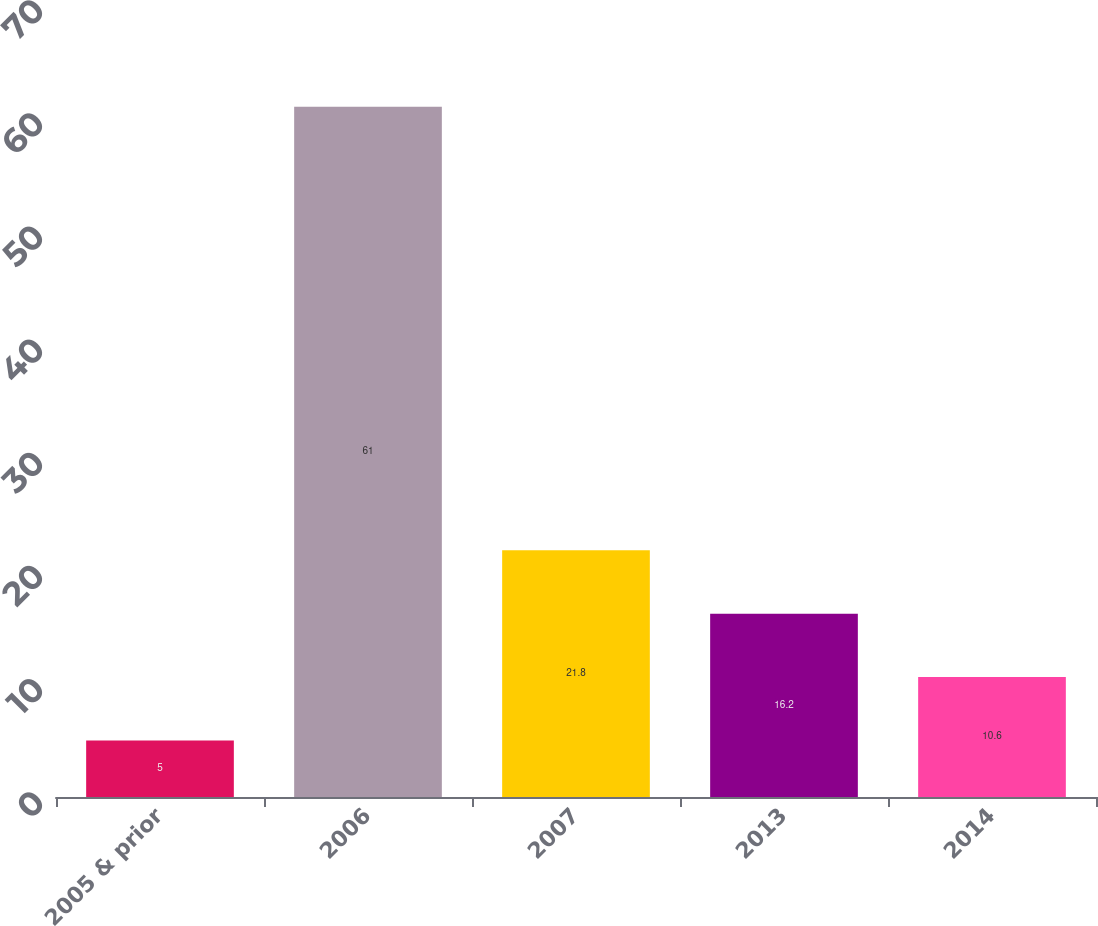Convert chart to OTSL. <chart><loc_0><loc_0><loc_500><loc_500><bar_chart><fcel>2005 & prior<fcel>2006<fcel>2007<fcel>2013<fcel>2014<nl><fcel>5<fcel>61<fcel>21.8<fcel>16.2<fcel>10.6<nl></chart> 